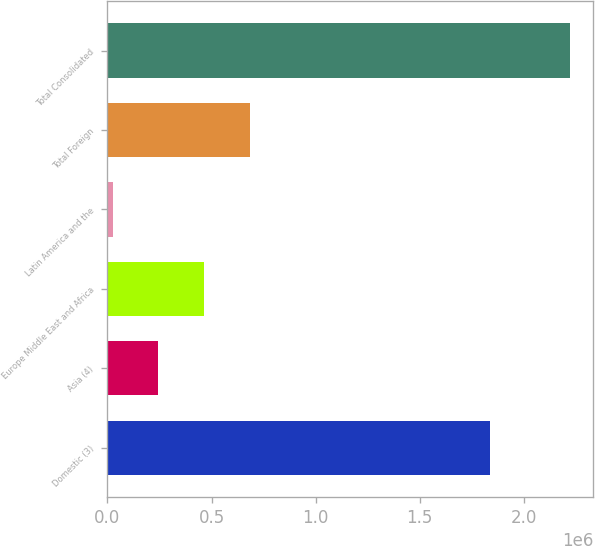Convert chart. <chart><loc_0><loc_0><loc_500><loc_500><bar_chart><fcel>Domestic (3)<fcel>Asia (4)<fcel>Europe Middle East and Africa<fcel>Latin America and the<fcel>Total Foreign<fcel>Total Consolidated<nl><fcel>1.84023e+06<fcel>244625<fcel>464477<fcel>24772<fcel>684330<fcel>2.2233e+06<nl></chart> 